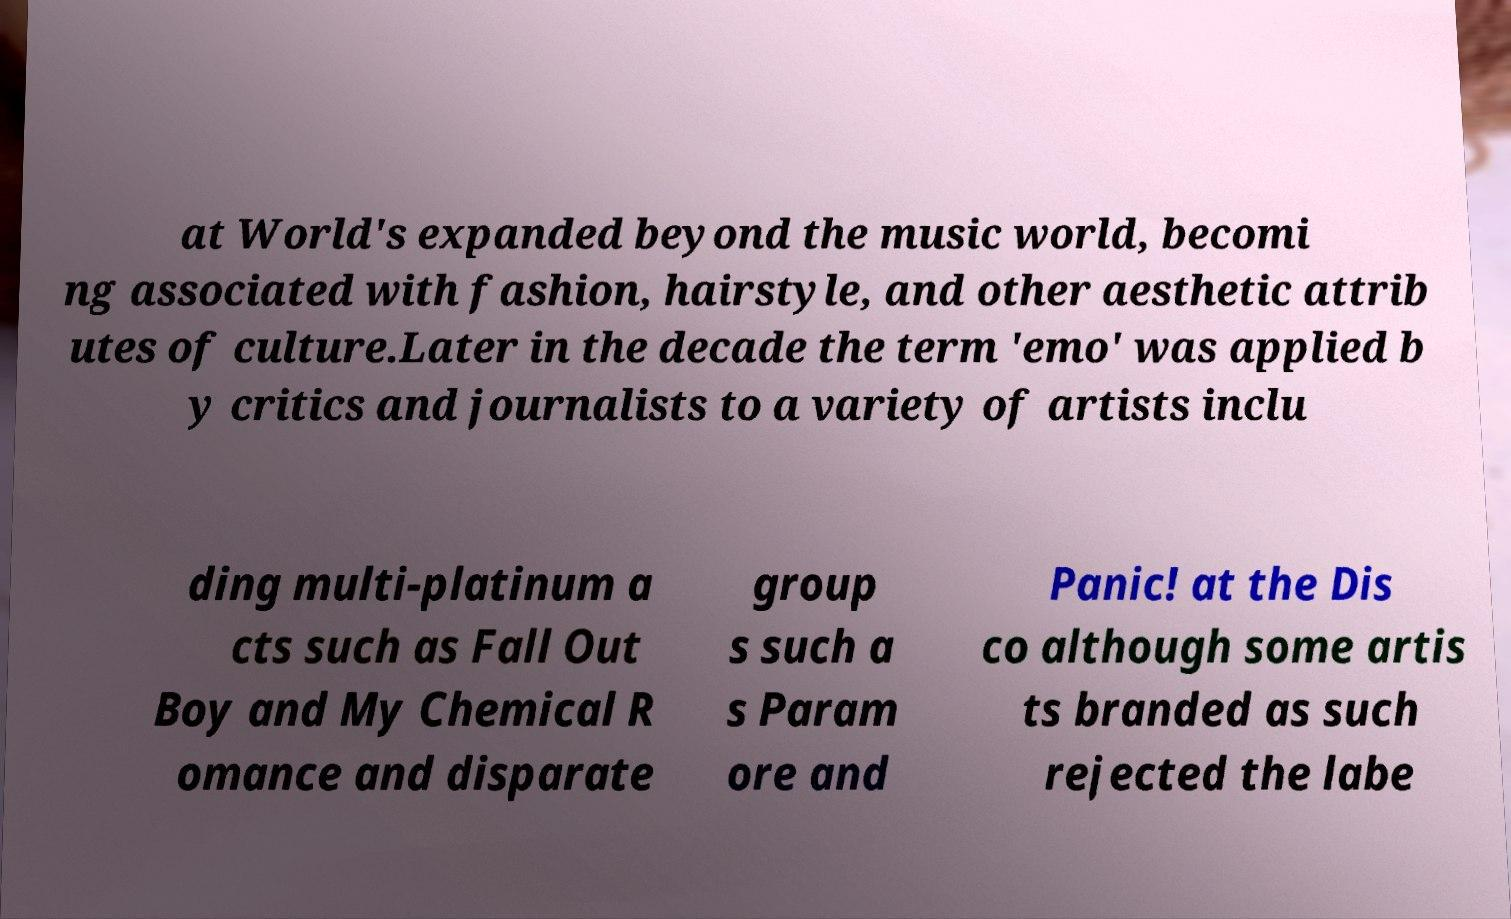Could you extract and type out the text from this image? at World's expanded beyond the music world, becomi ng associated with fashion, hairstyle, and other aesthetic attrib utes of culture.Later in the decade the term 'emo' was applied b y critics and journalists to a variety of artists inclu ding multi-platinum a cts such as Fall Out Boy and My Chemical R omance and disparate group s such a s Param ore and Panic! at the Dis co although some artis ts branded as such rejected the labe 